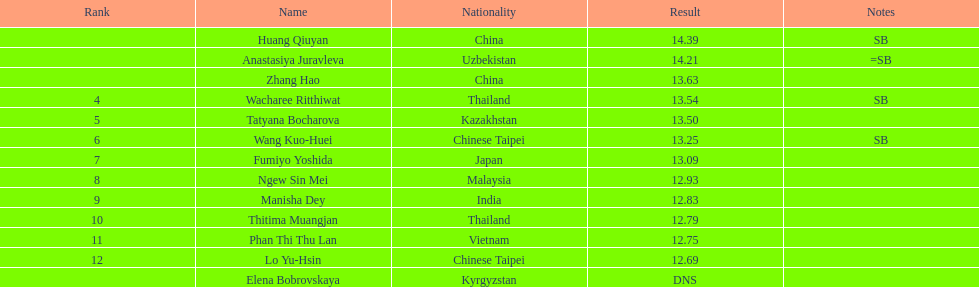Write the full table. {'header': ['Rank', 'Name', 'Nationality', 'Result', 'Notes'], 'rows': [['', 'Huang Qiuyan', 'China', '14.39', 'SB'], ['', 'Anastasiya Juravleva', 'Uzbekistan', '14.21', '=SB'], ['', 'Zhang Hao', 'China', '13.63', ''], ['4', 'Wacharee Ritthiwat', 'Thailand', '13.54', 'SB'], ['5', 'Tatyana Bocharova', 'Kazakhstan', '13.50', ''], ['6', 'Wang Kuo-Huei', 'Chinese Taipei', '13.25', 'SB'], ['7', 'Fumiyo Yoshida', 'Japan', '13.09', ''], ['8', 'Ngew Sin Mei', 'Malaysia', '12.93', ''], ['9', 'Manisha Dey', 'India', '12.83', ''], ['10', 'Thitima Muangjan', 'Thailand', '12.79', ''], ['11', 'Phan Thi Thu Lan', 'Vietnam', '12.75', ''], ['12', 'Lo Yu-Hsin', 'Chinese Taipei', '12.69', ''], ['', 'Elena Bobrovskaya', 'Kyrgyzstan', 'DNS', '']]} How many contestants were from thailand? 2. 